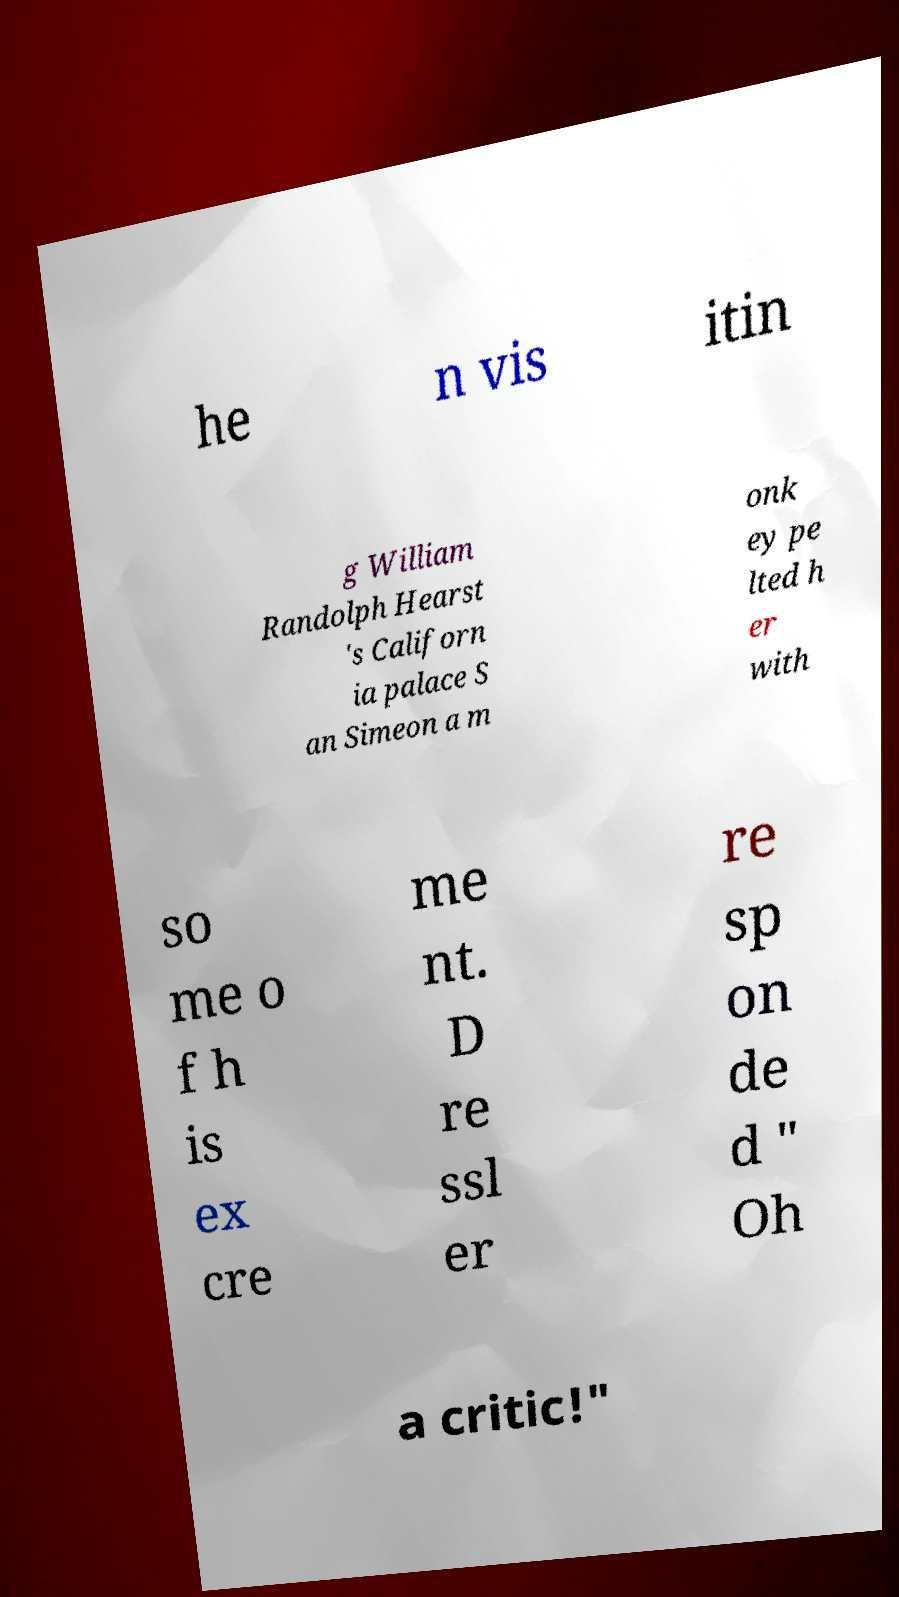There's text embedded in this image that I need extracted. Can you transcribe it verbatim? he n vis itin g William Randolph Hearst 's Californ ia palace S an Simeon a m onk ey pe lted h er with so me o f h is ex cre me nt. D re ssl er re sp on de d " Oh a critic!" 